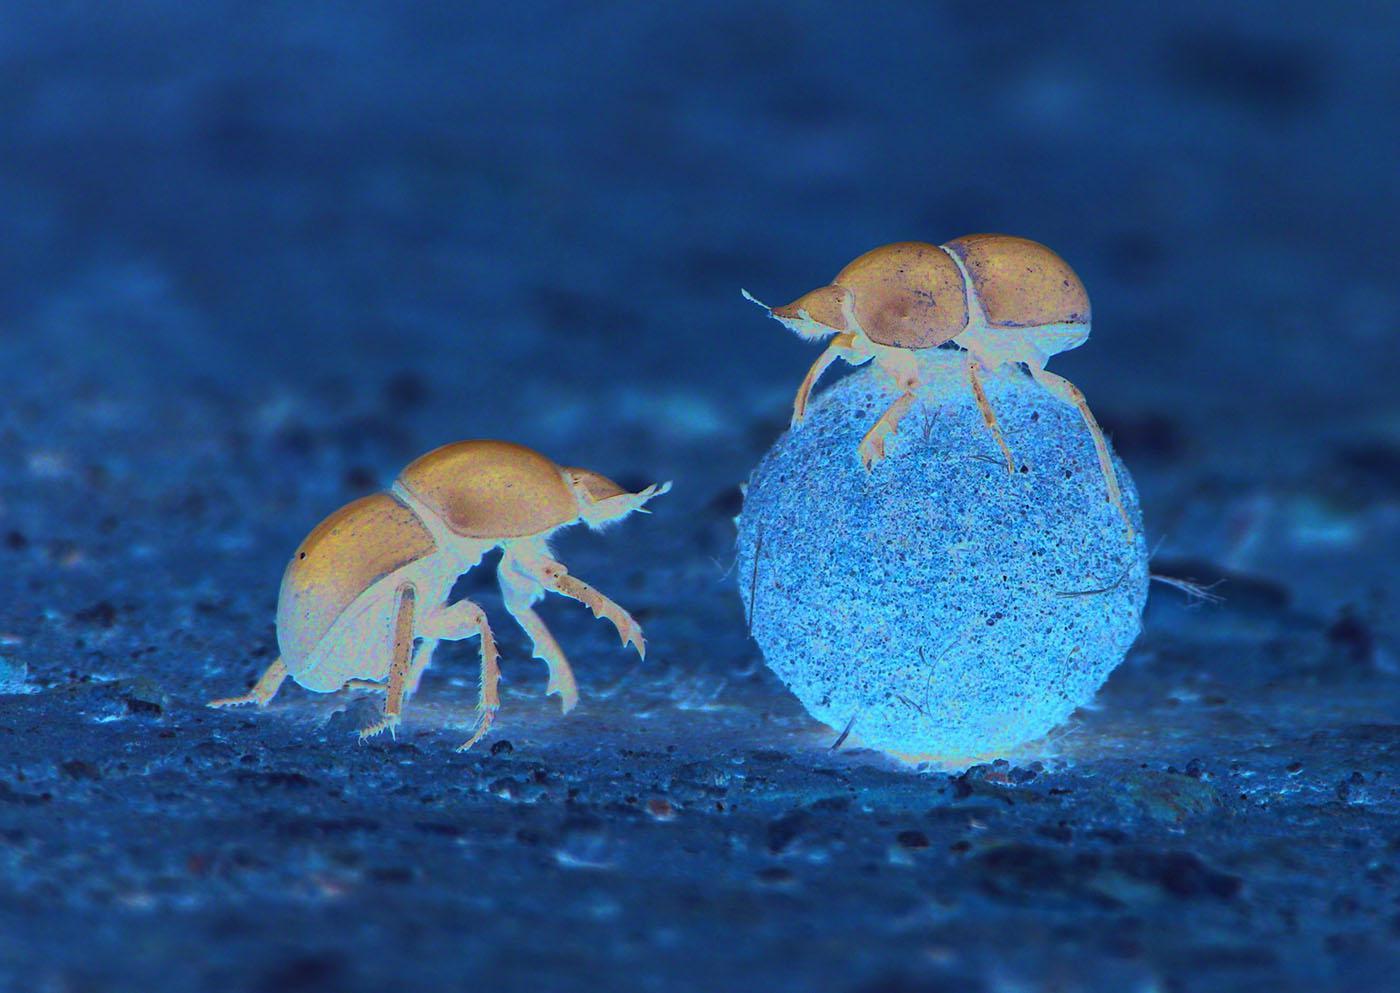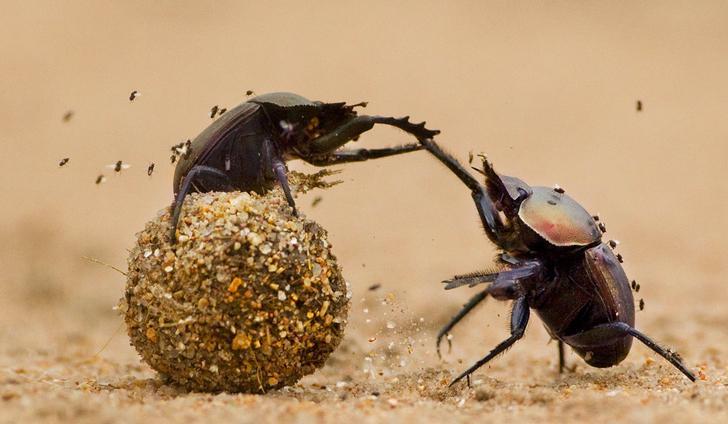The first image is the image on the left, the second image is the image on the right. Evaluate the accuracy of this statement regarding the images: "There is more than four beetles.". Is it true? Answer yes or no. Yes. The first image is the image on the left, the second image is the image on the right. Analyze the images presented: Is the assertion "There are two black dung beetles touching both the ground and the dung circle." valid? Answer yes or no. No. 